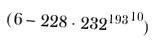<formula> <loc_0><loc_0><loc_500><loc_500>( 6 - 2 2 8 \cdot { 2 3 2 ^ { 1 9 3 } } ^ { 1 0 } )</formula> 